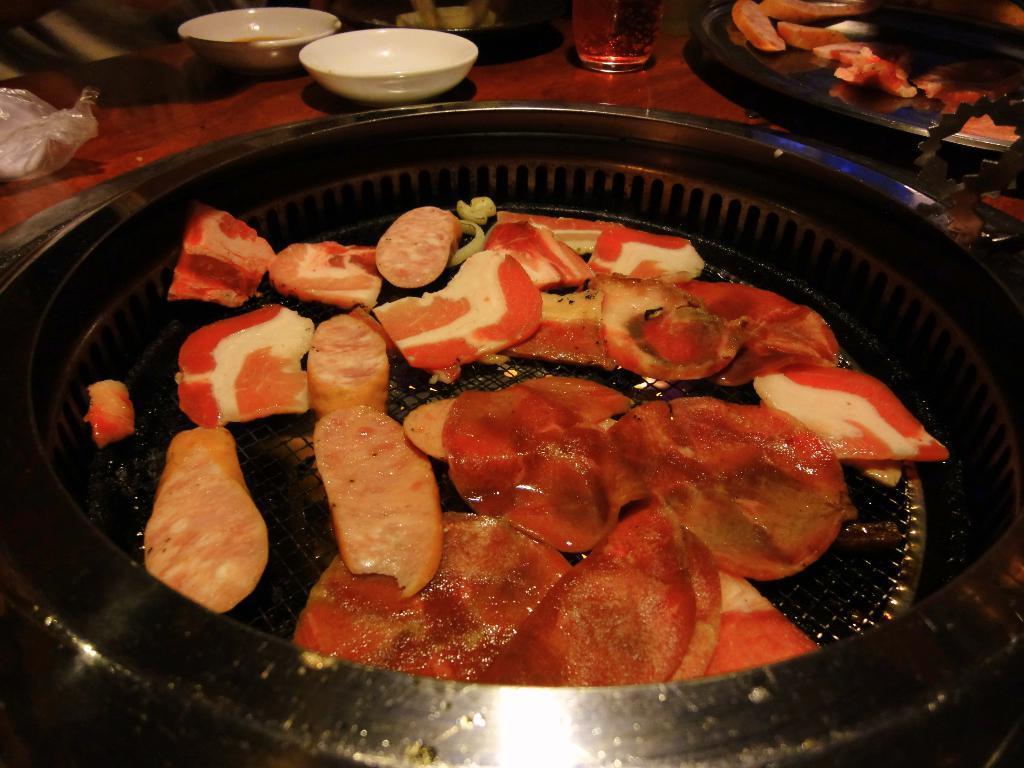In one or two sentences, can you explain what this image depicts? In the picture I can see food items in plates. I can also see white color bowls, a glass and some other objects on a surface. 